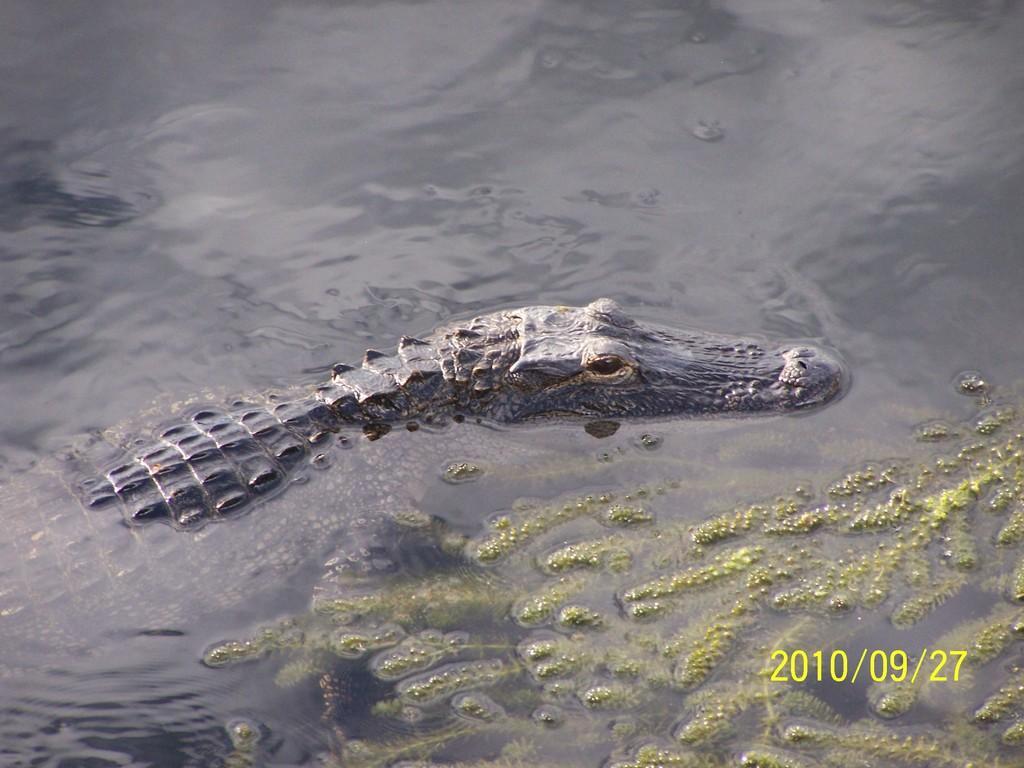In one or two sentences, can you explain what this image depicts? In this image there is a crocodile in the water. On the right side of the image there is algae. There is some text at the bottom of the image. 